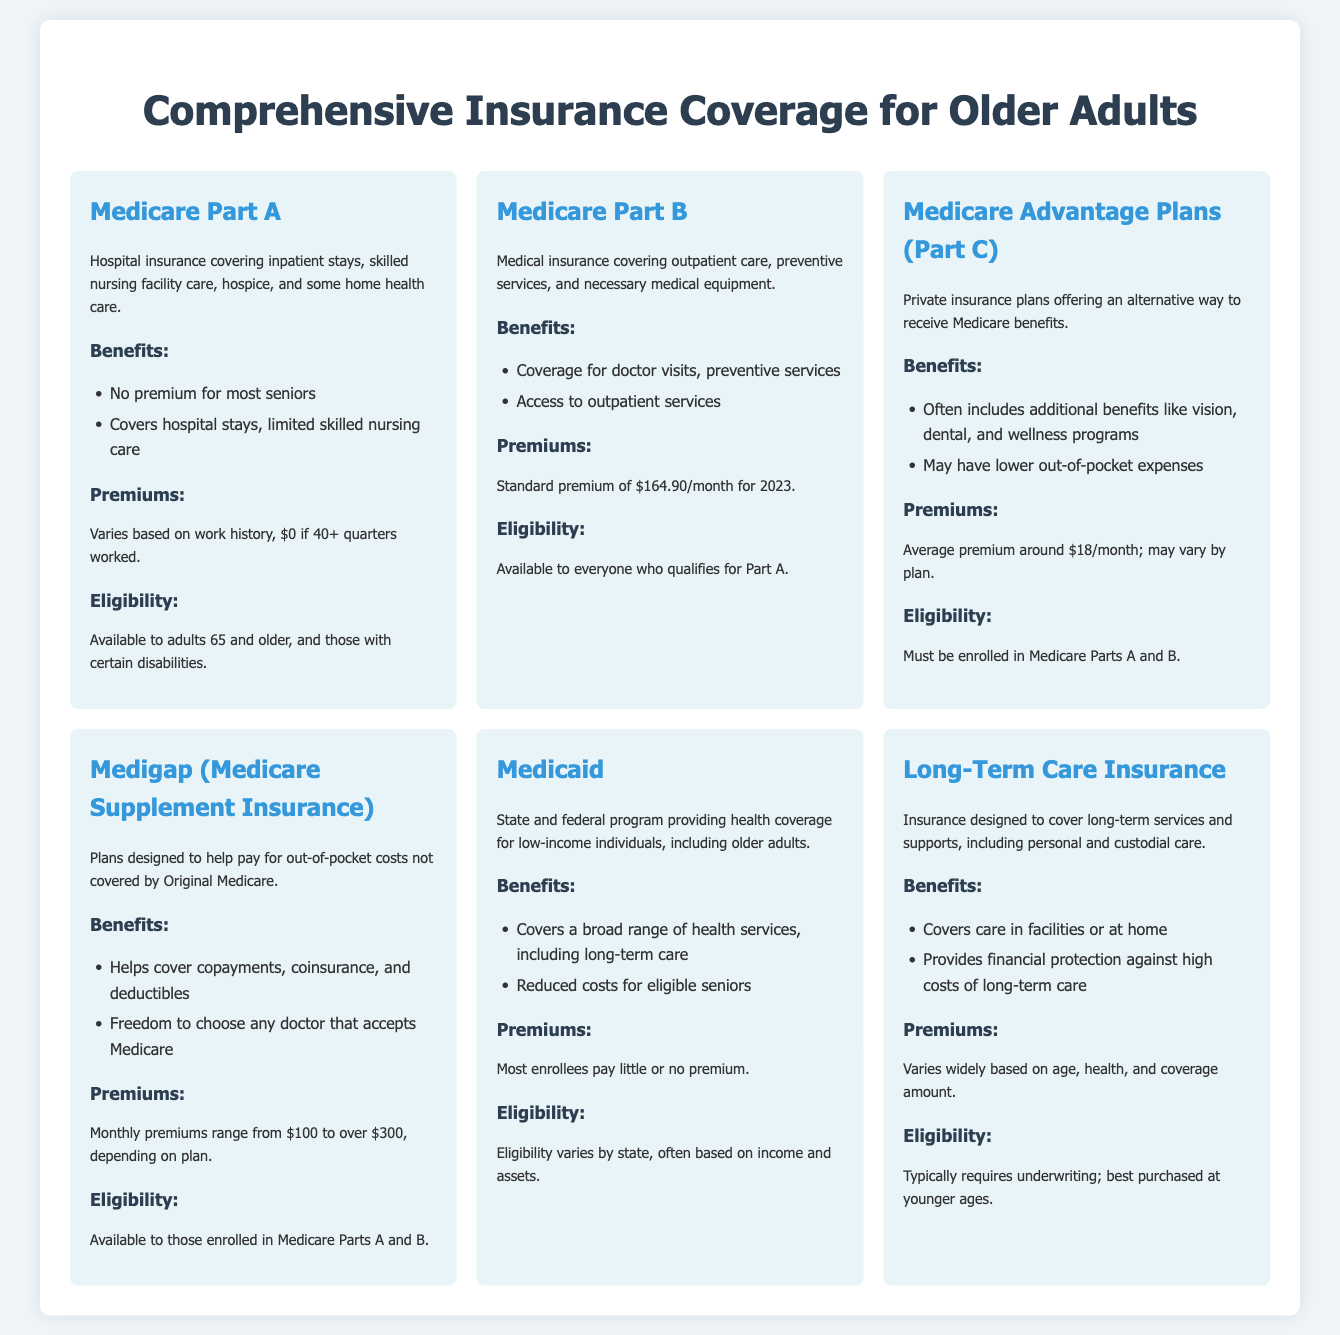What is the standard premium for Medicare Part B in 2023? The premium for Medicare Part B is stated in the document as $164.90/month for 2023.
Answer: $164.90/month What type of coverage does Medicare Part A provide? Medicare Part A is described as hospital insurance covering inpatient stays, skilled nursing facility care, hospice, and some home health care.
Answer: Hospital insurance What are the monthly premiums for Medigap? The document states that monthly premiums for Medigap range from $100 to over $300, depending on the plan.
Answer: $100 to over $300 Who is eligible for Medicaid? Eligibility for Medicaid varies by state and is often based on income and assets, as explained in the document.
Answer: Income and assets What additional benefits might Medicare Advantage Plans include? The document mentions that Medicare Advantage Plans often include additional benefits like vision, dental, and wellness programs.
Answer: Vision, dental, wellness programs Which document describes health coverage for low-income individuals? The document that describes health coverage for low-income individuals, including older adults, is Medicaid.
Answer: Medicaid What insurance covers long-term services and supports? The insurance designed to cover long-term services and supports, including personal and custodial care, is Long-Term Care Insurance.
Answer: Long-Term Care Insurance What is required to qualify for Medigap? The document states that to qualify for Medigap, one must be enrolled in Medicare Parts A and B.
Answer: Enrolled in Medicare Parts A and B 